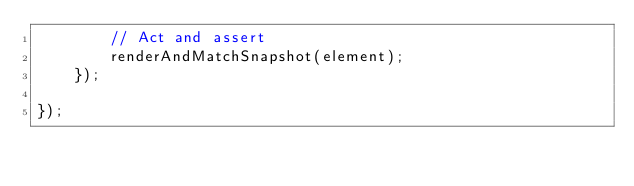<code> <loc_0><loc_0><loc_500><loc_500><_TypeScript_>        // Act and assert
        renderAndMatchSnapshot(element);
    });

});
</code> 